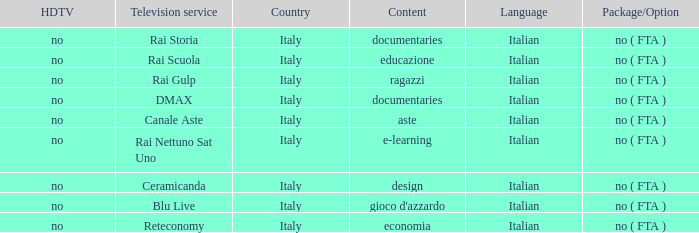What is the HDTV for the Rai Nettuno Sat Uno Television service? No. 